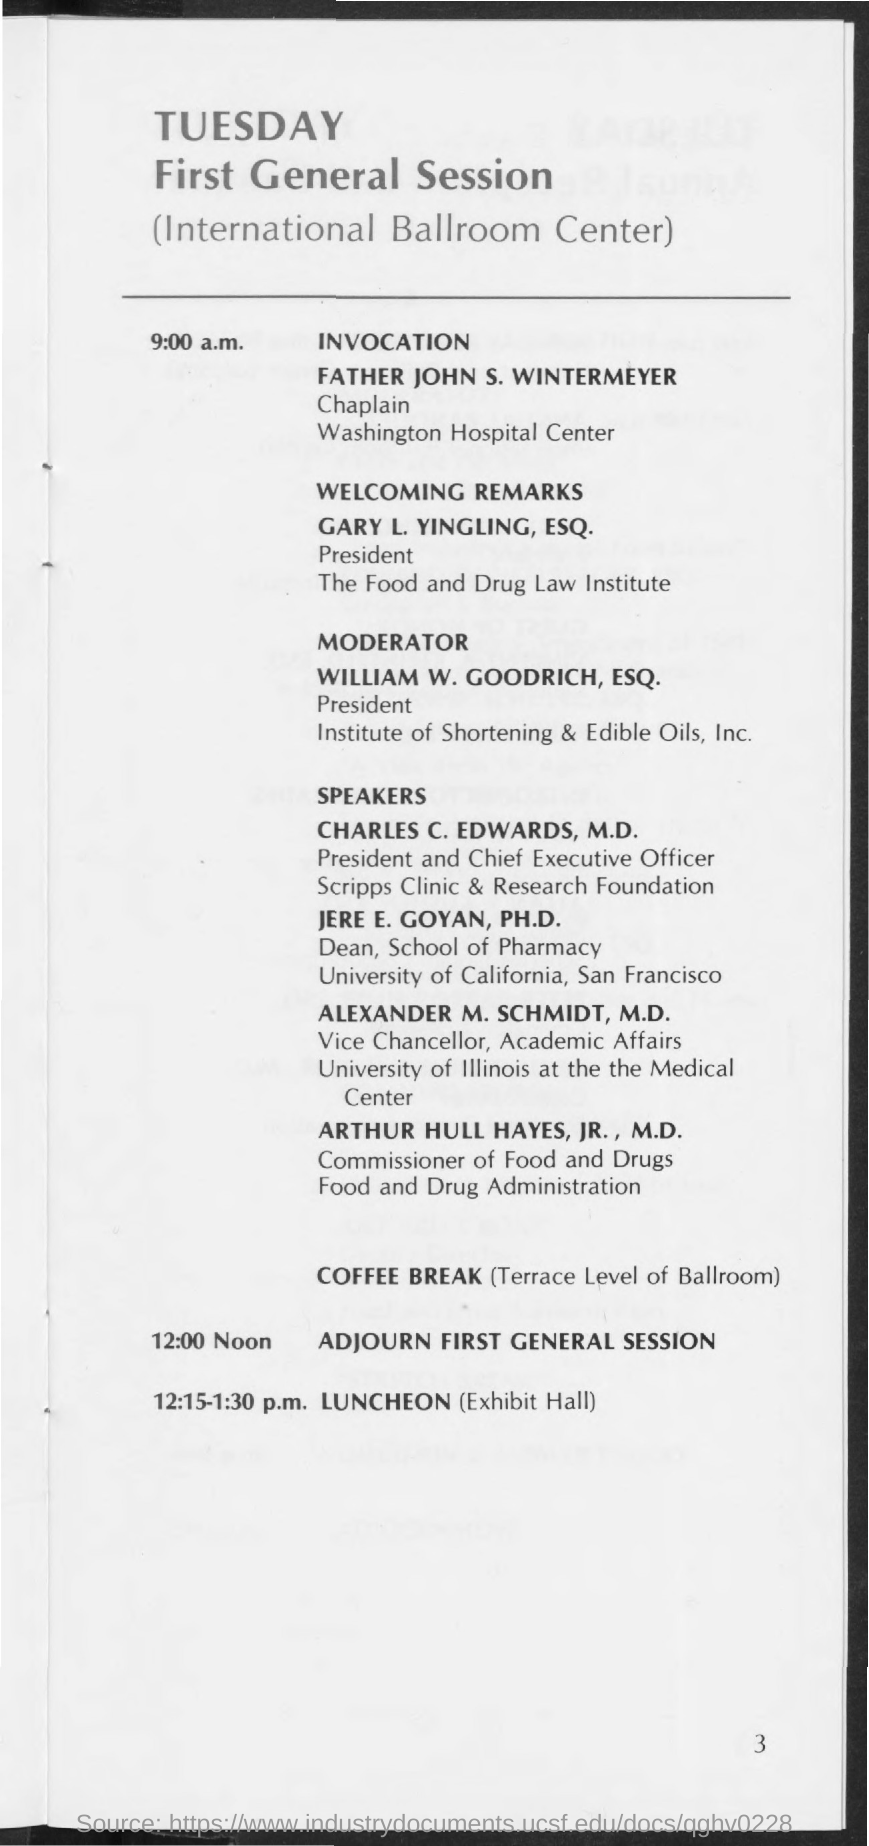What day of the week is mentioned in the document?
Provide a succinct answer. Tuesday. Which general session is held on tuesday?
Your answer should be compact. First General Session. Where is the first general session held at ?
Make the answer very short. (International Ballroom Center). Who is the chaplain of washington hospital center?
Ensure brevity in your answer.  Father John S. Wintermeyer. Who is the president of institute of shortening and edible oils, inc.?
Make the answer very short. William W. Goodrich, Esq. Who is dean of school of pharmacy, university of california?
Provide a short and direct response. Jere E. Goyan, Ph.D. Who is the president and chief executive officer of scripps clinic & research foundation?
Make the answer very short. Charles C. Edwards, M.D. Who is the vice chancellor, academic affairs of university of illinois at the medical center?
Make the answer very short. Alexander M. Schmidt, M.D. Who is the commissioner of food and drugs of food and drug adminstration?
Offer a very short reply. Arthur Hull Hayes, Jr., M.D. 